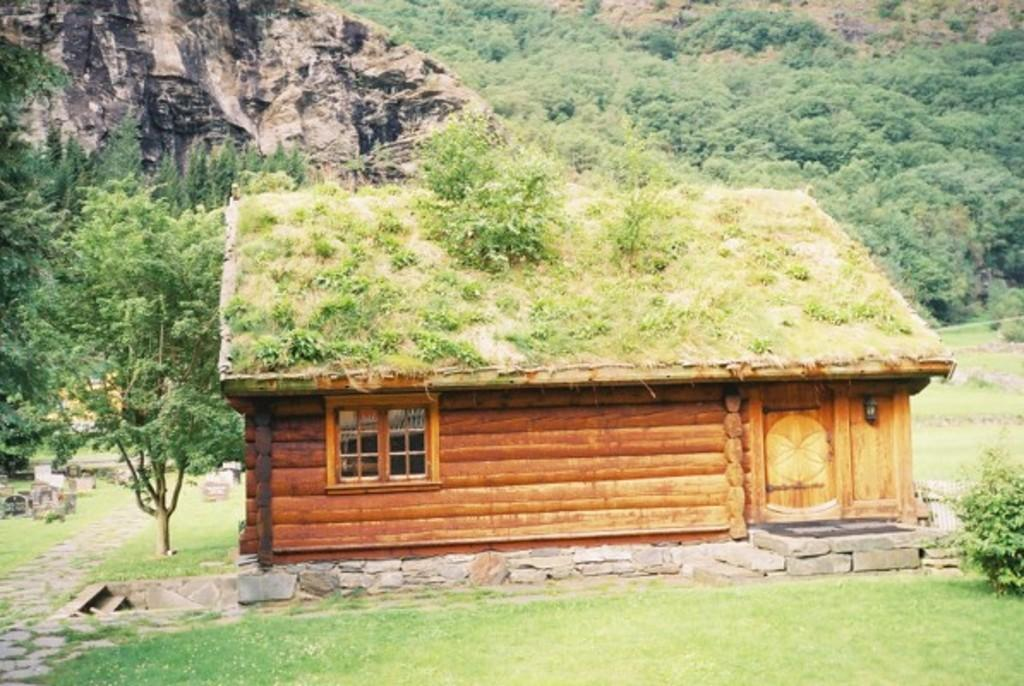What type of structure can be seen in the image? There is a shed in the image. What feature does the shed have? The shed has a window. What type of barrier is present in the image? There is a fence in the image. What type of natural elements are present in the image? Plants and rocks are visible in the image. What can be seen in the background of the image? There are trees and a hill visible in the background of the image. What type of creature is playing with the rice in the image? There is no creature or rice present in the image. 